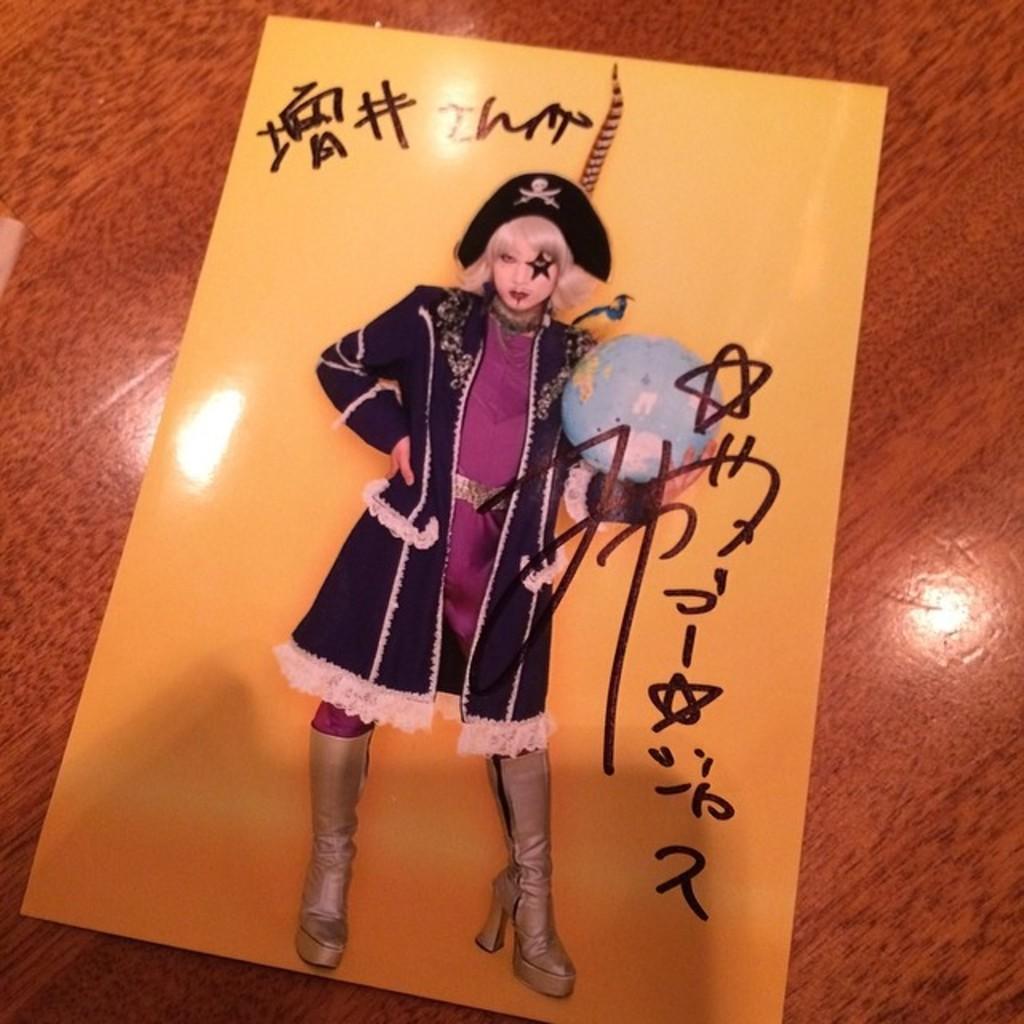In one or two sentences, can you explain what this image depicts? In this picture we can see the image of a woman on the paper and the woman is in the fancy dress. She is holding a globe. On the paper, it is written something and the paper is on the wooden object. 